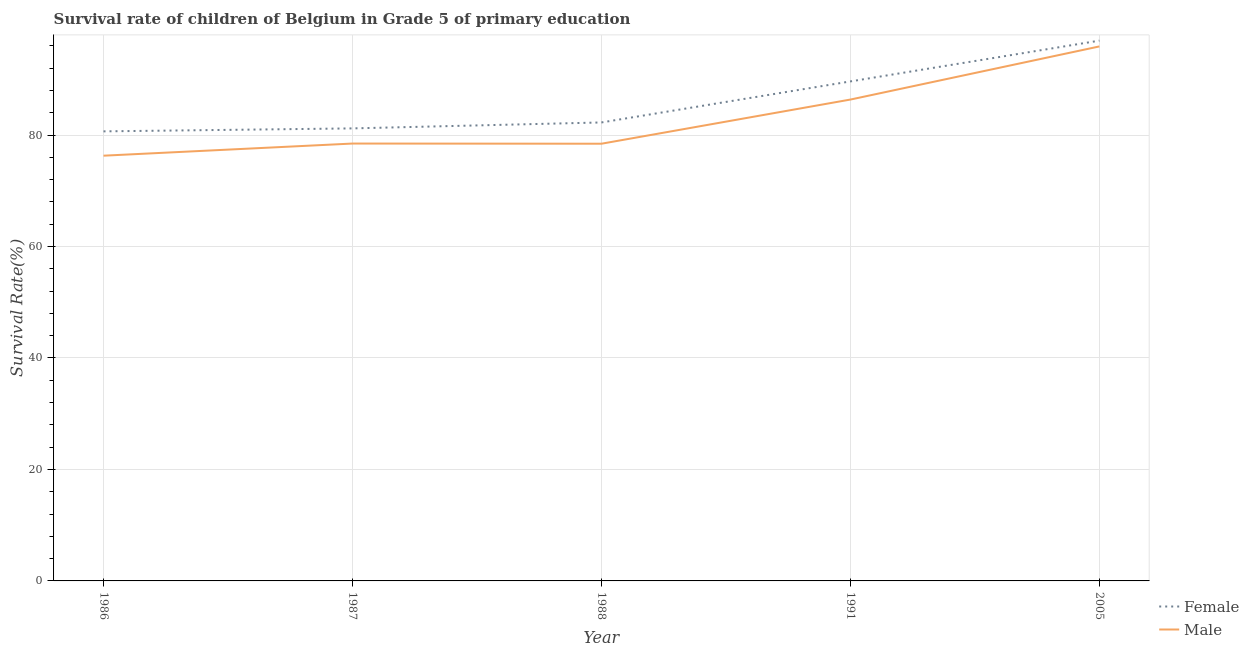How many different coloured lines are there?
Offer a very short reply. 2. Does the line corresponding to survival rate of male students in primary education intersect with the line corresponding to survival rate of female students in primary education?
Offer a very short reply. No. What is the survival rate of female students in primary education in 1991?
Offer a terse response. 89.63. Across all years, what is the maximum survival rate of male students in primary education?
Keep it short and to the point. 95.91. Across all years, what is the minimum survival rate of female students in primary education?
Make the answer very short. 80.67. In which year was the survival rate of male students in primary education minimum?
Your answer should be very brief. 1986. What is the total survival rate of female students in primary education in the graph?
Keep it short and to the point. 430.7. What is the difference between the survival rate of female students in primary education in 1986 and that in 1991?
Offer a terse response. -8.96. What is the difference between the survival rate of male students in primary education in 1986 and the survival rate of female students in primary education in 2005?
Provide a succinct answer. -20.65. What is the average survival rate of male students in primary education per year?
Offer a very short reply. 83.1. In the year 1988, what is the difference between the survival rate of female students in primary education and survival rate of male students in primary education?
Your answer should be very brief. 3.82. In how many years, is the survival rate of male students in primary education greater than 60 %?
Keep it short and to the point. 5. What is the ratio of the survival rate of female students in primary education in 1986 to that in 1987?
Offer a terse response. 0.99. Is the survival rate of male students in primary education in 1986 less than that in 1987?
Ensure brevity in your answer.  Yes. Is the difference between the survival rate of female students in primary education in 1987 and 1988 greater than the difference between the survival rate of male students in primary education in 1987 and 1988?
Your answer should be very brief. No. What is the difference between the highest and the second highest survival rate of female students in primary education?
Keep it short and to the point. 7.32. What is the difference between the highest and the lowest survival rate of male students in primary education?
Provide a succinct answer. 19.61. In how many years, is the survival rate of male students in primary education greater than the average survival rate of male students in primary education taken over all years?
Make the answer very short. 2. Does the survival rate of male students in primary education monotonically increase over the years?
Your answer should be very brief. No. Is the survival rate of male students in primary education strictly less than the survival rate of female students in primary education over the years?
Offer a terse response. Yes. How many lines are there?
Ensure brevity in your answer.  2. What is the difference between two consecutive major ticks on the Y-axis?
Keep it short and to the point. 20. Does the graph contain any zero values?
Give a very brief answer. No. Where does the legend appear in the graph?
Your answer should be very brief. Bottom right. What is the title of the graph?
Provide a succinct answer. Survival rate of children of Belgium in Grade 5 of primary education. What is the label or title of the Y-axis?
Your response must be concise. Survival Rate(%). What is the Survival Rate(%) of Female in 1986?
Give a very brief answer. 80.67. What is the Survival Rate(%) of Male in 1986?
Your response must be concise. 76.3. What is the Survival Rate(%) of Female in 1987?
Keep it short and to the point. 81.2. What is the Survival Rate(%) of Male in 1987?
Make the answer very short. 78.48. What is the Survival Rate(%) in Female in 1988?
Provide a short and direct response. 82.26. What is the Survival Rate(%) in Male in 1988?
Provide a succinct answer. 78.45. What is the Survival Rate(%) of Female in 1991?
Give a very brief answer. 89.63. What is the Survival Rate(%) of Male in 1991?
Give a very brief answer. 86.37. What is the Survival Rate(%) of Female in 2005?
Give a very brief answer. 96.95. What is the Survival Rate(%) in Male in 2005?
Ensure brevity in your answer.  95.91. Across all years, what is the maximum Survival Rate(%) of Female?
Make the answer very short. 96.95. Across all years, what is the maximum Survival Rate(%) of Male?
Ensure brevity in your answer.  95.91. Across all years, what is the minimum Survival Rate(%) of Female?
Provide a short and direct response. 80.67. Across all years, what is the minimum Survival Rate(%) of Male?
Offer a terse response. 76.3. What is the total Survival Rate(%) of Female in the graph?
Offer a terse response. 430.7. What is the total Survival Rate(%) in Male in the graph?
Give a very brief answer. 415.5. What is the difference between the Survival Rate(%) of Female in 1986 and that in 1987?
Your answer should be compact. -0.53. What is the difference between the Survival Rate(%) of Male in 1986 and that in 1987?
Keep it short and to the point. -2.18. What is the difference between the Survival Rate(%) in Female in 1986 and that in 1988?
Provide a short and direct response. -1.6. What is the difference between the Survival Rate(%) of Male in 1986 and that in 1988?
Give a very brief answer. -2.15. What is the difference between the Survival Rate(%) in Female in 1986 and that in 1991?
Give a very brief answer. -8.96. What is the difference between the Survival Rate(%) of Male in 1986 and that in 1991?
Give a very brief answer. -10.07. What is the difference between the Survival Rate(%) in Female in 1986 and that in 2005?
Your answer should be very brief. -16.28. What is the difference between the Survival Rate(%) in Male in 1986 and that in 2005?
Offer a very short reply. -19.61. What is the difference between the Survival Rate(%) in Female in 1987 and that in 1988?
Offer a terse response. -1.07. What is the difference between the Survival Rate(%) in Male in 1987 and that in 1988?
Give a very brief answer. 0.03. What is the difference between the Survival Rate(%) in Female in 1987 and that in 1991?
Your answer should be compact. -8.43. What is the difference between the Survival Rate(%) in Male in 1987 and that in 1991?
Your answer should be compact. -7.89. What is the difference between the Survival Rate(%) of Female in 1987 and that in 2005?
Provide a short and direct response. -15.75. What is the difference between the Survival Rate(%) of Male in 1987 and that in 2005?
Your answer should be compact. -17.43. What is the difference between the Survival Rate(%) in Female in 1988 and that in 1991?
Make the answer very short. -7.36. What is the difference between the Survival Rate(%) of Male in 1988 and that in 1991?
Your answer should be very brief. -7.93. What is the difference between the Survival Rate(%) in Female in 1988 and that in 2005?
Provide a short and direct response. -14.68. What is the difference between the Survival Rate(%) in Male in 1988 and that in 2005?
Your response must be concise. -17.46. What is the difference between the Survival Rate(%) in Female in 1991 and that in 2005?
Offer a terse response. -7.32. What is the difference between the Survival Rate(%) in Male in 1991 and that in 2005?
Your response must be concise. -9.53. What is the difference between the Survival Rate(%) of Female in 1986 and the Survival Rate(%) of Male in 1987?
Offer a very short reply. 2.19. What is the difference between the Survival Rate(%) of Female in 1986 and the Survival Rate(%) of Male in 1988?
Give a very brief answer. 2.22. What is the difference between the Survival Rate(%) in Female in 1986 and the Survival Rate(%) in Male in 1991?
Give a very brief answer. -5.71. What is the difference between the Survival Rate(%) in Female in 1986 and the Survival Rate(%) in Male in 2005?
Provide a succinct answer. -15.24. What is the difference between the Survival Rate(%) in Female in 1987 and the Survival Rate(%) in Male in 1988?
Your answer should be very brief. 2.75. What is the difference between the Survival Rate(%) in Female in 1987 and the Survival Rate(%) in Male in 1991?
Give a very brief answer. -5.17. What is the difference between the Survival Rate(%) in Female in 1987 and the Survival Rate(%) in Male in 2005?
Offer a very short reply. -14.71. What is the difference between the Survival Rate(%) of Female in 1988 and the Survival Rate(%) of Male in 1991?
Give a very brief answer. -4.11. What is the difference between the Survival Rate(%) of Female in 1988 and the Survival Rate(%) of Male in 2005?
Your answer should be compact. -13.64. What is the difference between the Survival Rate(%) of Female in 1991 and the Survival Rate(%) of Male in 2005?
Your answer should be compact. -6.28. What is the average Survival Rate(%) of Female per year?
Your response must be concise. 86.14. What is the average Survival Rate(%) of Male per year?
Provide a succinct answer. 83.1. In the year 1986, what is the difference between the Survival Rate(%) in Female and Survival Rate(%) in Male?
Give a very brief answer. 4.37. In the year 1987, what is the difference between the Survival Rate(%) of Female and Survival Rate(%) of Male?
Offer a terse response. 2.72. In the year 1988, what is the difference between the Survival Rate(%) of Female and Survival Rate(%) of Male?
Provide a succinct answer. 3.82. In the year 1991, what is the difference between the Survival Rate(%) in Female and Survival Rate(%) in Male?
Offer a terse response. 3.26. In the year 2005, what is the difference between the Survival Rate(%) of Female and Survival Rate(%) of Male?
Make the answer very short. 1.04. What is the ratio of the Survival Rate(%) in Female in 1986 to that in 1987?
Your response must be concise. 0.99. What is the ratio of the Survival Rate(%) in Male in 1986 to that in 1987?
Ensure brevity in your answer.  0.97. What is the ratio of the Survival Rate(%) in Female in 1986 to that in 1988?
Your answer should be compact. 0.98. What is the ratio of the Survival Rate(%) of Male in 1986 to that in 1988?
Ensure brevity in your answer.  0.97. What is the ratio of the Survival Rate(%) of Male in 1986 to that in 1991?
Your response must be concise. 0.88. What is the ratio of the Survival Rate(%) in Female in 1986 to that in 2005?
Make the answer very short. 0.83. What is the ratio of the Survival Rate(%) of Male in 1986 to that in 2005?
Your response must be concise. 0.8. What is the ratio of the Survival Rate(%) in Female in 1987 to that in 1991?
Provide a succinct answer. 0.91. What is the ratio of the Survival Rate(%) in Male in 1987 to that in 1991?
Your answer should be very brief. 0.91. What is the ratio of the Survival Rate(%) in Female in 1987 to that in 2005?
Make the answer very short. 0.84. What is the ratio of the Survival Rate(%) in Male in 1987 to that in 2005?
Provide a succinct answer. 0.82. What is the ratio of the Survival Rate(%) of Female in 1988 to that in 1991?
Provide a short and direct response. 0.92. What is the ratio of the Survival Rate(%) in Male in 1988 to that in 1991?
Make the answer very short. 0.91. What is the ratio of the Survival Rate(%) in Female in 1988 to that in 2005?
Your response must be concise. 0.85. What is the ratio of the Survival Rate(%) of Male in 1988 to that in 2005?
Provide a short and direct response. 0.82. What is the ratio of the Survival Rate(%) of Female in 1991 to that in 2005?
Your response must be concise. 0.92. What is the ratio of the Survival Rate(%) of Male in 1991 to that in 2005?
Provide a short and direct response. 0.9. What is the difference between the highest and the second highest Survival Rate(%) of Female?
Your answer should be very brief. 7.32. What is the difference between the highest and the second highest Survival Rate(%) in Male?
Your response must be concise. 9.53. What is the difference between the highest and the lowest Survival Rate(%) in Female?
Your answer should be very brief. 16.28. What is the difference between the highest and the lowest Survival Rate(%) in Male?
Give a very brief answer. 19.61. 